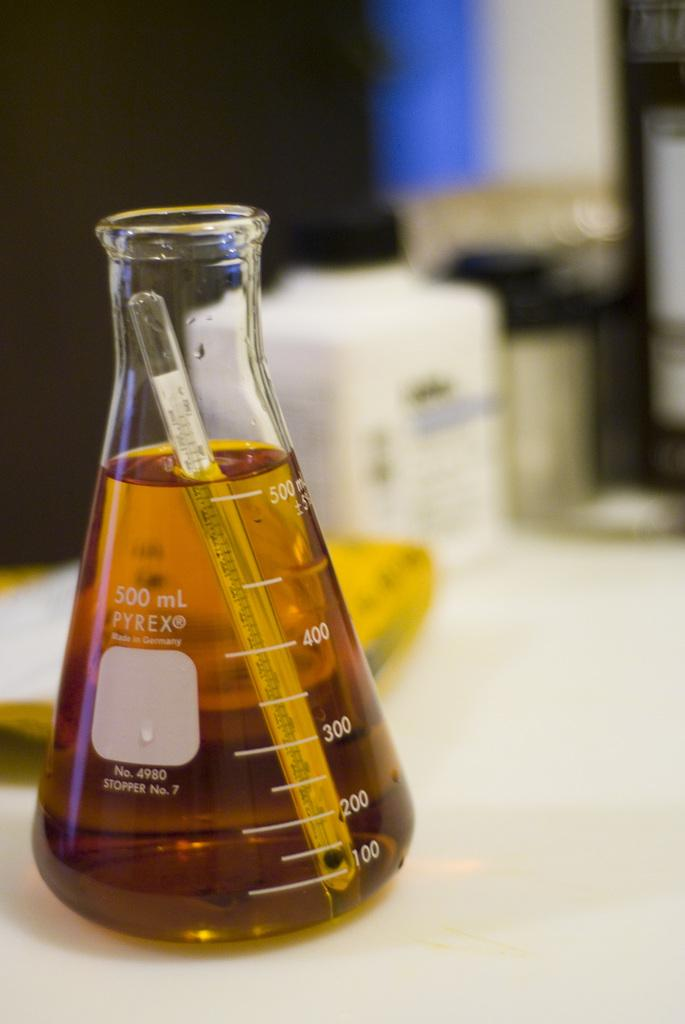<image>
Share a concise interpretation of the image provided. A Pyrex beaker filled with a brown liquid. 